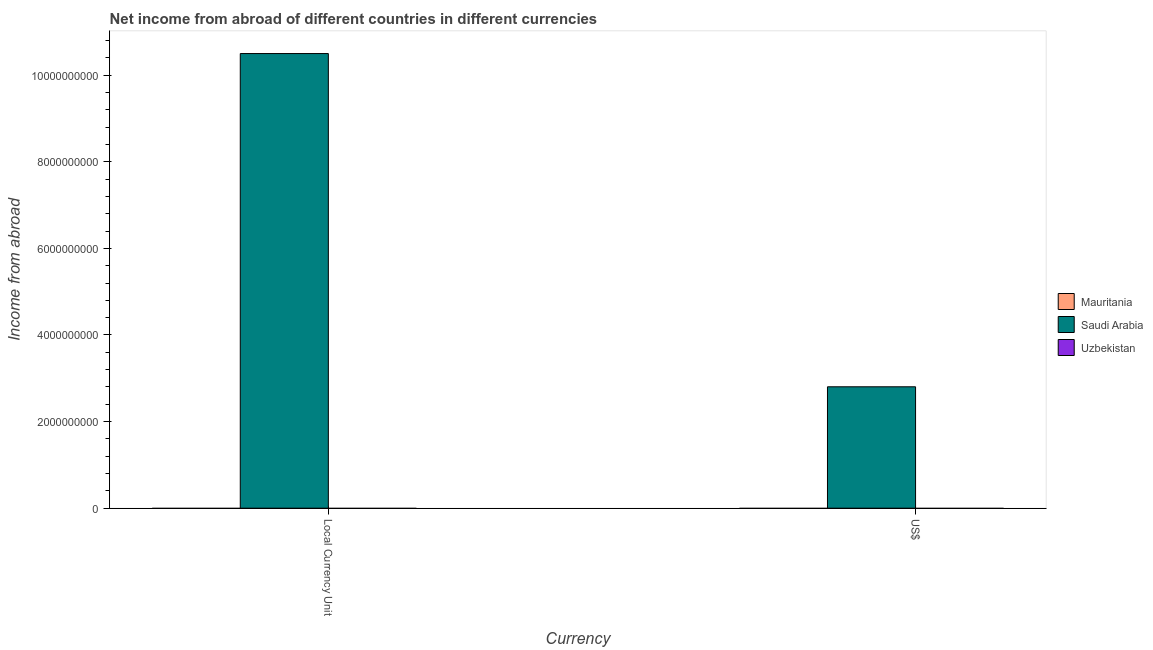How many different coloured bars are there?
Keep it short and to the point. 1. Are the number of bars on each tick of the X-axis equal?
Offer a very short reply. Yes. How many bars are there on the 1st tick from the right?
Provide a succinct answer. 1. What is the label of the 2nd group of bars from the left?
Your answer should be compact. US$. What is the income from abroad in us$ in Saudi Arabia?
Your response must be concise. 2.80e+09. Across all countries, what is the maximum income from abroad in us$?
Provide a short and direct response. 2.80e+09. In which country was the income from abroad in us$ maximum?
Your answer should be very brief. Saudi Arabia. What is the total income from abroad in constant 2005 us$ in the graph?
Your answer should be very brief. 1.05e+1. What is the difference between the income from abroad in us$ in Saudi Arabia and the income from abroad in constant 2005 us$ in Mauritania?
Your response must be concise. 2.80e+09. What is the average income from abroad in us$ per country?
Provide a short and direct response. 9.34e+08. What is the difference between the income from abroad in us$ and income from abroad in constant 2005 us$ in Saudi Arabia?
Ensure brevity in your answer.  -7.70e+09. In how many countries, is the income from abroad in us$ greater than 1600000000 units?
Give a very brief answer. 1. In how many countries, is the income from abroad in constant 2005 us$ greater than the average income from abroad in constant 2005 us$ taken over all countries?
Your response must be concise. 1. How many bars are there?
Give a very brief answer. 2. What is the difference between two consecutive major ticks on the Y-axis?
Keep it short and to the point. 2.00e+09. Are the values on the major ticks of Y-axis written in scientific E-notation?
Give a very brief answer. No. Does the graph contain grids?
Make the answer very short. No. How many legend labels are there?
Ensure brevity in your answer.  3. How are the legend labels stacked?
Provide a short and direct response. Vertical. What is the title of the graph?
Make the answer very short. Net income from abroad of different countries in different currencies. What is the label or title of the X-axis?
Provide a succinct answer. Currency. What is the label or title of the Y-axis?
Your answer should be compact. Income from abroad. What is the Income from abroad in Saudi Arabia in Local Currency Unit?
Give a very brief answer. 1.05e+1. What is the Income from abroad of Uzbekistan in Local Currency Unit?
Your response must be concise. 0. What is the Income from abroad in Mauritania in US$?
Offer a terse response. 0. What is the Income from abroad of Saudi Arabia in US$?
Keep it short and to the point. 2.80e+09. What is the Income from abroad of Uzbekistan in US$?
Ensure brevity in your answer.  0. Across all Currency, what is the maximum Income from abroad in Saudi Arabia?
Your answer should be very brief. 1.05e+1. Across all Currency, what is the minimum Income from abroad of Saudi Arabia?
Give a very brief answer. 2.80e+09. What is the total Income from abroad of Mauritania in the graph?
Ensure brevity in your answer.  0. What is the total Income from abroad of Saudi Arabia in the graph?
Ensure brevity in your answer.  1.33e+1. What is the difference between the Income from abroad of Saudi Arabia in Local Currency Unit and that in US$?
Ensure brevity in your answer.  7.70e+09. What is the average Income from abroad in Saudi Arabia per Currency?
Make the answer very short. 6.65e+09. What is the average Income from abroad of Uzbekistan per Currency?
Give a very brief answer. 0. What is the ratio of the Income from abroad in Saudi Arabia in Local Currency Unit to that in US$?
Provide a short and direct response. 3.75. What is the difference between the highest and the second highest Income from abroad of Saudi Arabia?
Offer a very short reply. 7.70e+09. What is the difference between the highest and the lowest Income from abroad of Saudi Arabia?
Offer a very short reply. 7.70e+09. 